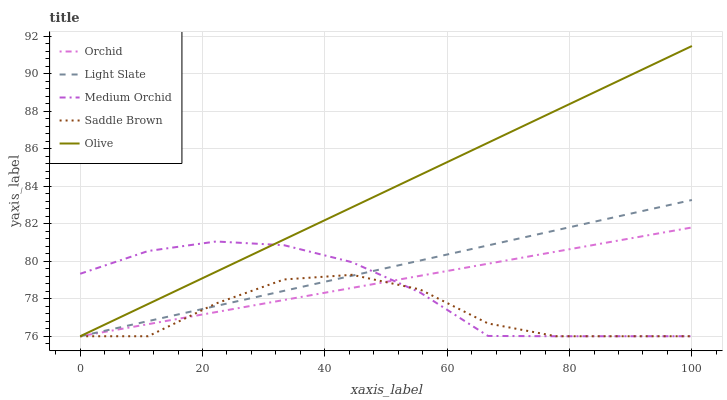Does Saddle Brown have the minimum area under the curve?
Answer yes or no. Yes. Does Olive have the maximum area under the curve?
Answer yes or no. Yes. Does Medium Orchid have the minimum area under the curve?
Answer yes or no. No. Does Medium Orchid have the maximum area under the curve?
Answer yes or no. No. Is Orchid the smoothest?
Answer yes or no. Yes. Is Saddle Brown the roughest?
Answer yes or no. Yes. Is Olive the smoothest?
Answer yes or no. No. Is Olive the roughest?
Answer yes or no. No. Does Olive have the highest value?
Answer yes or no. Yes. Does Medium Orchid have the highest value?
Answer yes or no. No. Does Olive intersect Light Slate?
Answer yes or no. Yes. Is Olive less than Light Slate?
Answer yes or no. No. Is Olive greater than Light Slate?
Answer yes or no. No. 